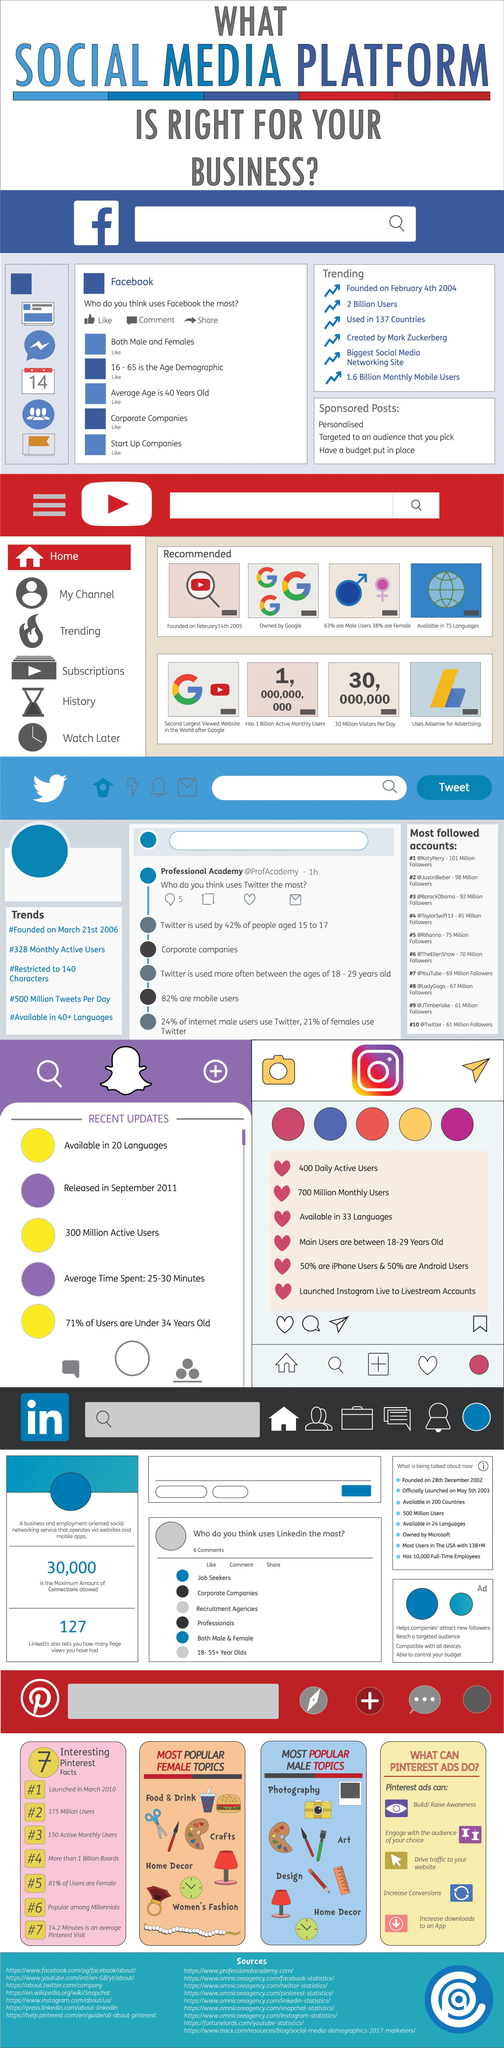Specify some key components in this picture. The maximum amount of connections allowed is 30,000. The number of the most popular female topics is 8. What is the number of the most popular male topics? It is 10. 